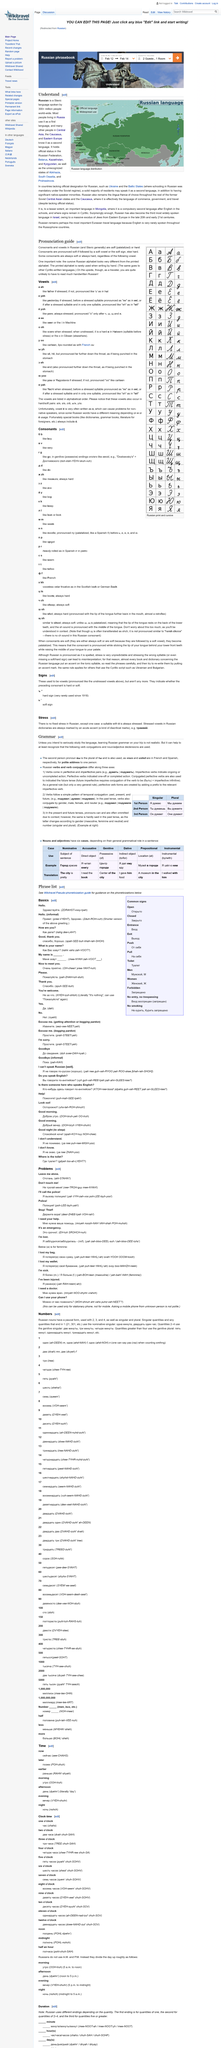Outline some significant characteristics in this image. Russian verbs and verb conjugation differ along three axes. The fact is, some Russian consonants are always soft or always hard. Learning Russian grammar for the purpose of serious study is not realistic unless you have a clear intention to do so. The cursive Russian alphabet significantly differs from the printed version, revealing a unique and elegant style. Conjugated perfective verbs are used to indicate the future tense. 